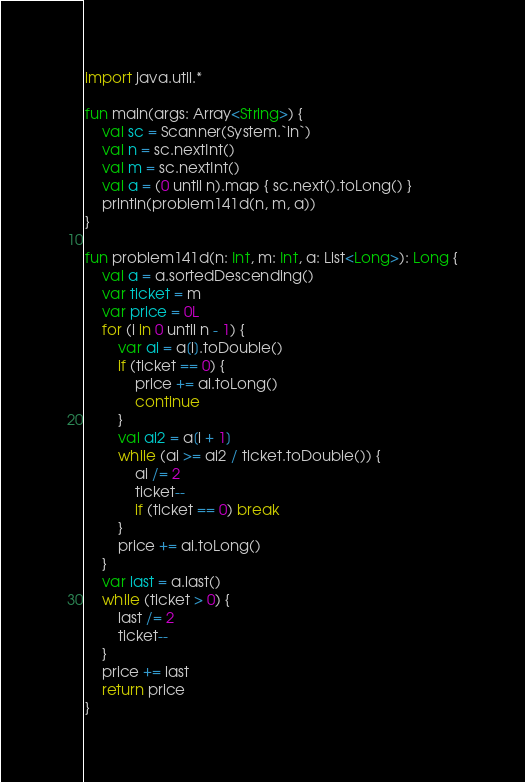<code> <loc_0><loc_0><loc_500><loc_500><_Kotlin_>import java.util.*

fun main(args: Array<String>) {
    val sc = Scanner(System.`in`)
    val n = sc.nextInt()
    val m = sc.nextInt()
    val a = (0 until n).map { sc.next().toLong() }
    println(problem141d(n, m, a))
}

fun problem141d(n: Int, m: Int, a: List<Long>): Long {
    val a = a.sortedDescending()
    var ticket = m
    var price = 0L
    for (i in 0 until n - 1) {
        var ai = a[i].toDouble()
        if (ticket == 0) {
            price += ai.toLong()
            continue
        }
        val ai2 = a[i + 1]
        while (ai >= ai2 / ticket.toDouble()) {
            ai /= 2
            ticket--
            if (ticket == 0) break
        }
        price += ai.toLong()
    }
    var last = a.last()
    while (ticket > 0) {
        last /= 2
        ticket--
    }
    price += last
    return price
}</code> 